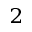<formula> <loc_0><loc_0><loc_500><loc_500>^ { 2 }</formula> 